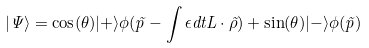Convert formula to latex. <formula><loc_0><loc_0><loc_500><loc_500>| \Psi \rangle = \cos ( \theta ) | + \rangle \phi ( \vec { p } - \int \epsilon d t { L } \cdot \vec { \rho } ) + \sin ( \theta ) | - \rangle \phi ( \vec { p } )</formula> 